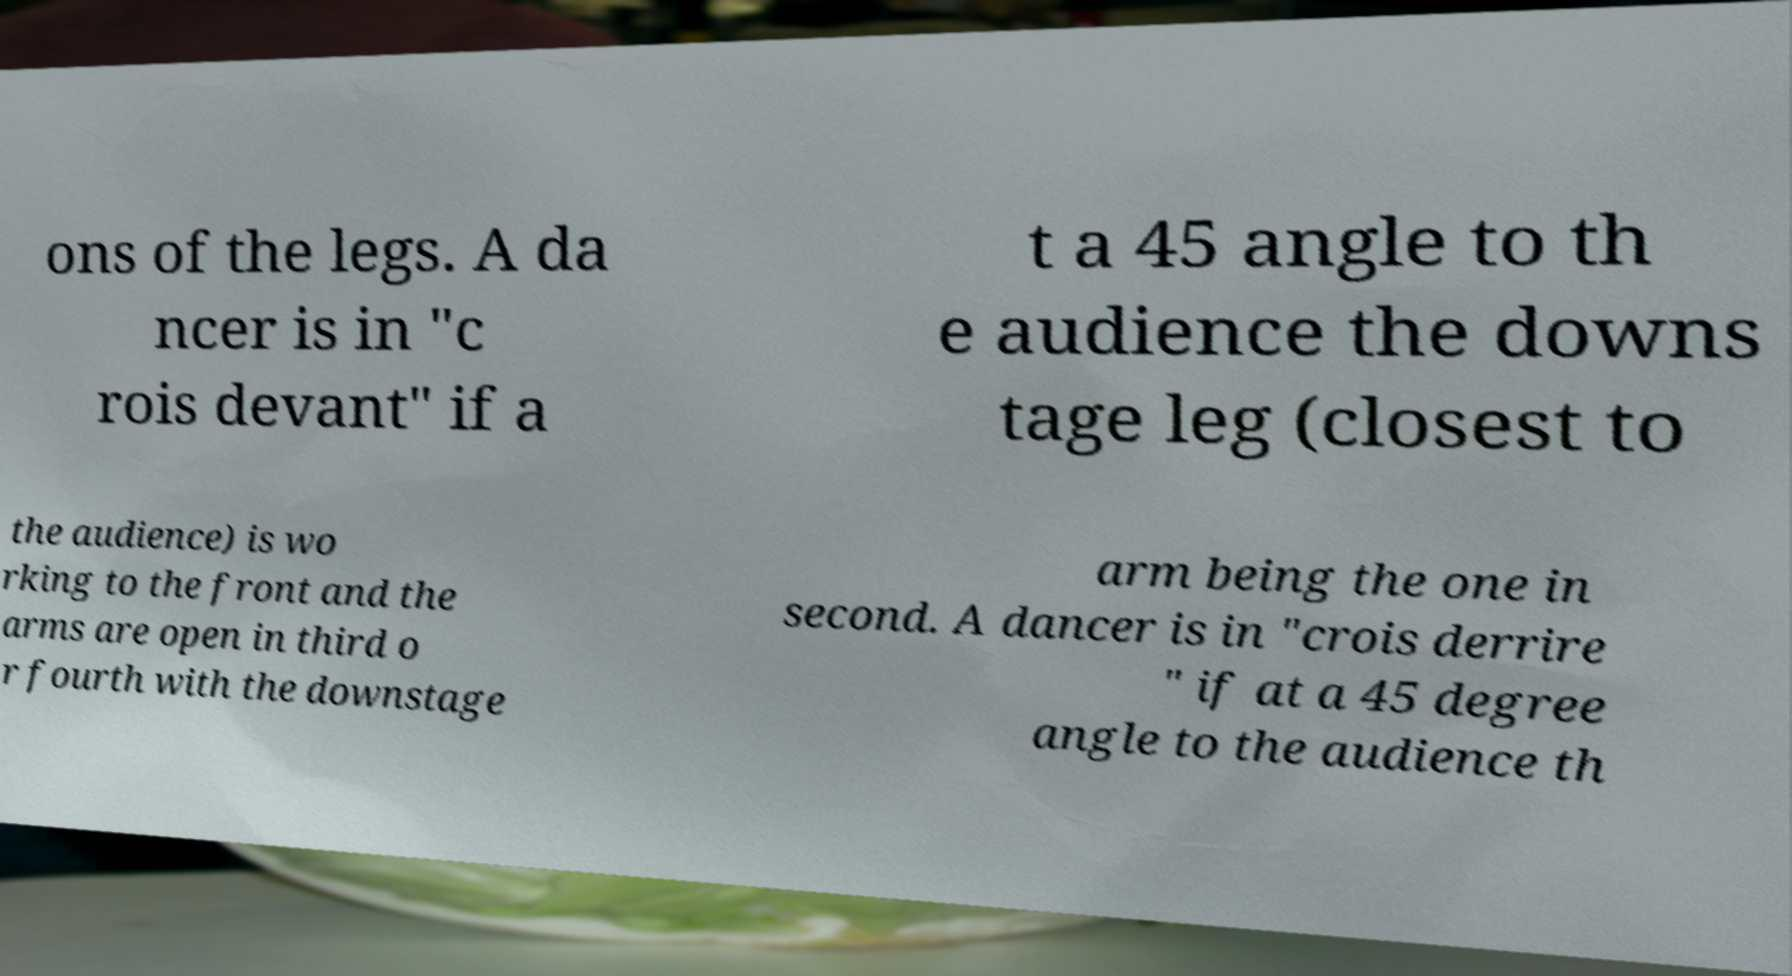Could you assist in decoding the text presented in this image and type it out clearly? ons of the legs. A da ncer is in "c rois devant" if a t a 45 angle to th e audience the downs tage leg (closest to the audience) is wo rking to the front and the arms are open in third o r fourth with the downstage arm being the one in second. A dancer is in "crois derrire " if at a 45 degree angle to the audience th 